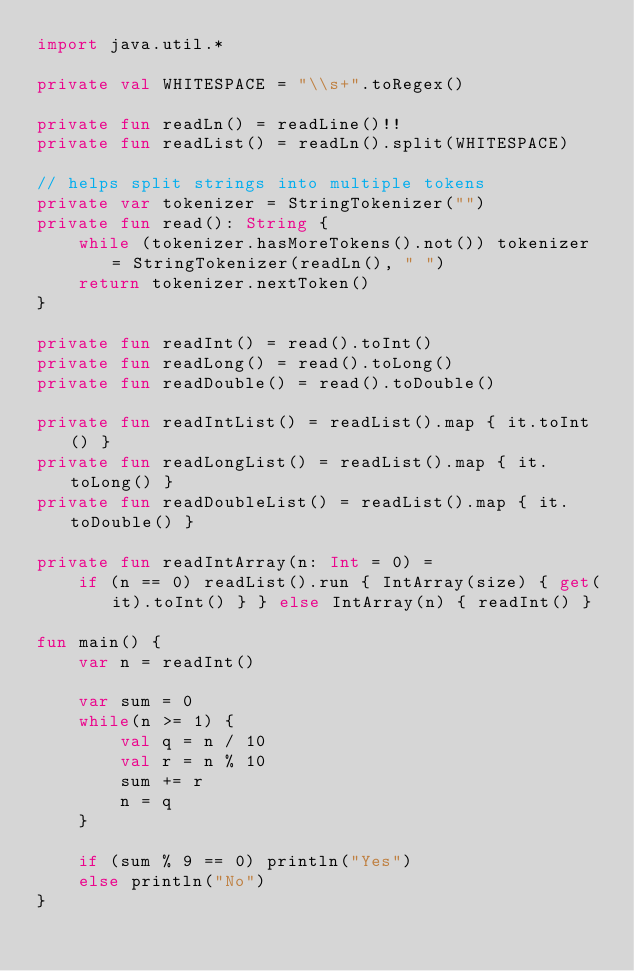Convert code to text. <code><loc_0><loc_0><loc_500><loc_500><_Kotlin_>import java.util.*

private val WHITESPACE = "\\s+".toRegex()

private fun readLn() = readLine()!!
private fun readList() = readLn().split(WHITESPACE)

// helps split strings into multiple tokens
private var tokenizer = StringTokenizer("")
private fun read(): String {
    while (tokenizer.hasMoreTokens().not()) tokenizer = StringTokenizer(readLn(), " ")
    return tokenizer.nextToken()
}

private fun readInt() = read().toInt()
private fun readLong() = read().toLong()
private fun readDouble() = read().toDouble()

private fun readIntList() = readList().map { it.toInt() }
private fun readLongList() = readList().map { it.toLong() }
private fun readDoubleList() = readList().map { it.toDouble() }

private fun readIntArray(n: Int = 0) =
    if (n == 0) readList().run { IntArray(size) { get(it).toInt() } } else IntArray(n) { readInt() }

fun main() {
    var n = readInt()

    var sum = 0
    while(n >= 1) {
        val q = n / 10
        val r = n % 10
        sum += r
        n = q
    }

    if (sum % 9 == 0) println("Yes")
    else println("No")
}</code> 